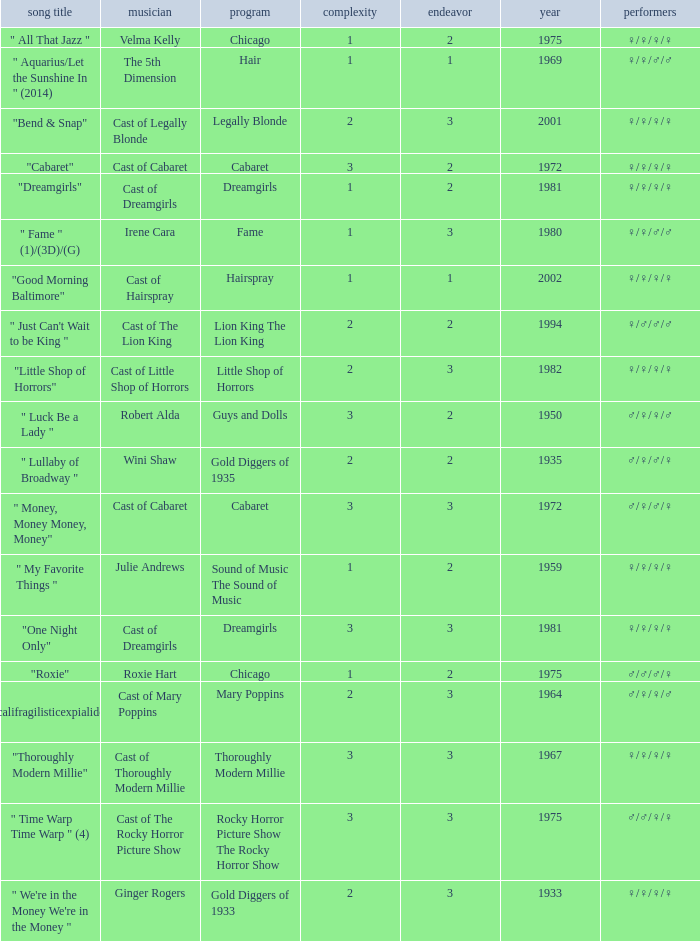How many artists were there for the show thoroughly modern millie? 1.0. 